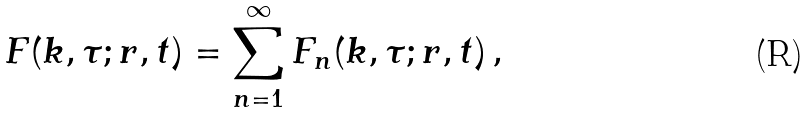Convert formula to latex. <formula><loc_0><loc_0><loc_500><loc_500>F ( { k } , \tau ; { r } , t ) = \sum _ { n = 1 } ^ { \infty } F _ { n } ( { k } , \tau ; { r } , t ) \, ,</formula> 